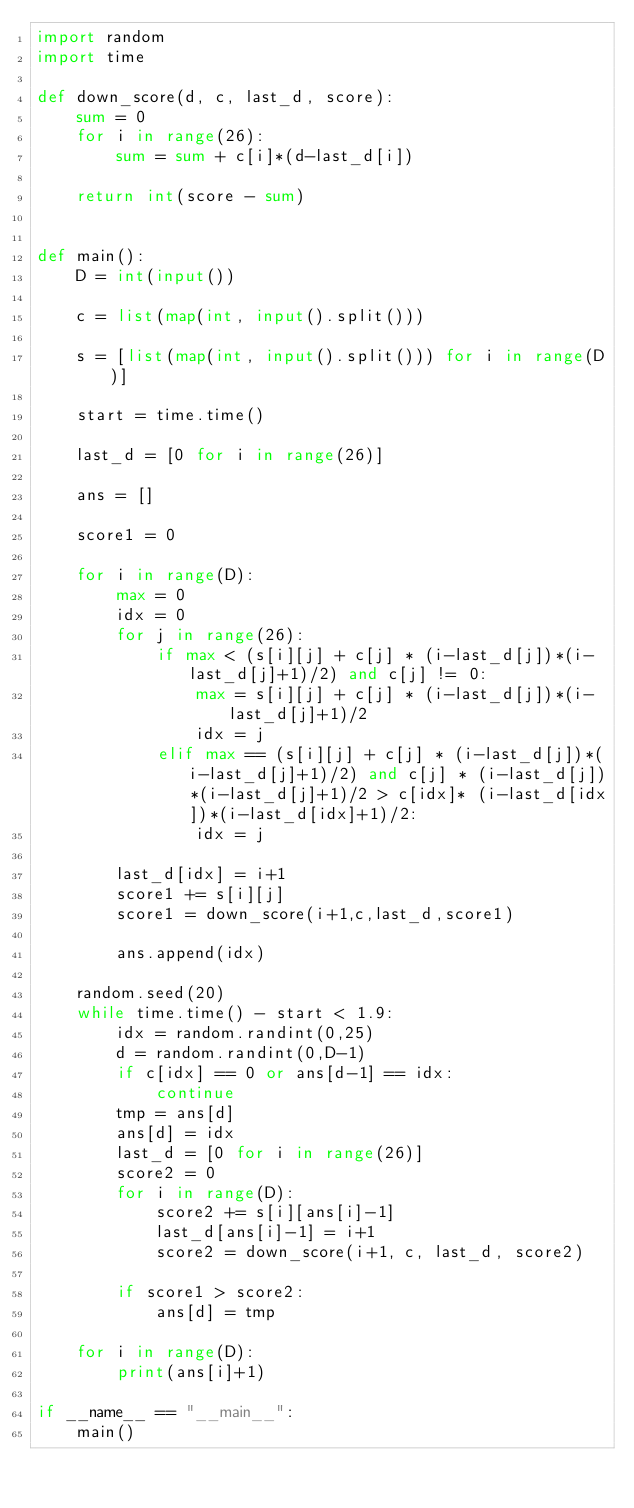Convert code to text. <code><loc_0><loc_0><loc_500><loc_500><_Python_>import random
import time

def down_score(d, c, last_d, score):
    sum = 0
    for i in range(26):
        sum = sum + c[i]*(d-last_d[i])
        
    return int(score - sum)


def main():
    D = int(input())

    c = list(map(int, input().split()))

    s = [list(map(int, input().split())) for i in range(D)]

    start = time.time()
    
    last_d = [0 for i in range(26)]
    
    ans = []
    
    score1 = 0
    
    for i in range(D):
        max = 0
        idx = 0
        for j in range(26):
            if max < (s[i][j] + c[j] * (i-last_d[j])*(i-last_d[j]+1)/2) and c[j] != 0:
                max = s[i][j] + c[j] * (i-last_d[j])*(i-last_d[j]+1)/2
                idx = j
            elif max == (s[i][j] + c[j] * (i-last_d[j])*(i-last_d[j]+1)/2) and c[j] * (i-last_d[j])*(i-last_d[j]+1)/2 > c[idx]* (i-last_d[idx])*(i-last_d[idx]+1)/2:
                idx = j
            
        last_d[idx] = i+1
        score1 += s[i][j]
        score1 = down_score(i+1,c,last_d,score1)
        
        ans.append(idx)

    random.seed(20)
    while time.time() - start < 1.9:
        idx = random.randint(0,25)
        d = random.randint(0,D-1)
        if c[idx] == 0 or ans[d-1] == idx:
            continue
        tmp = ans[d]
        ans[d] = idx
        last_d = [0 for i in range(26)]
        score2 = 0    
        for i in range(D):
            score2 += s[i][ans[i]-1]
            last_d[ans[i]-1] = i+1
            score2 = down_score(i+1, c, last_d, score2)
        
        if score1 > score2:
            ans[d] = tmp
    
    for i in range(D):
        print(ans[i]+1)  

if __name__ == "__main__":
    main()
</code> 